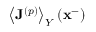Convert formula to latex. <formula><loc_0><loc_0><loc_500><loc_500>\left \langle J ^ { \left ( p \right ) } \right \rangle _ { Y } ( x ^ { - } )</formula> 